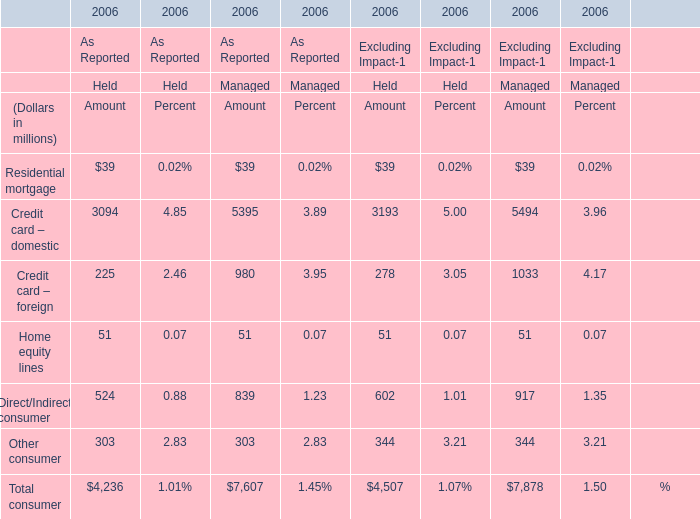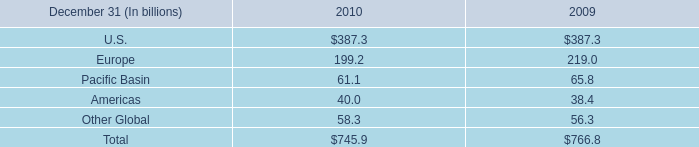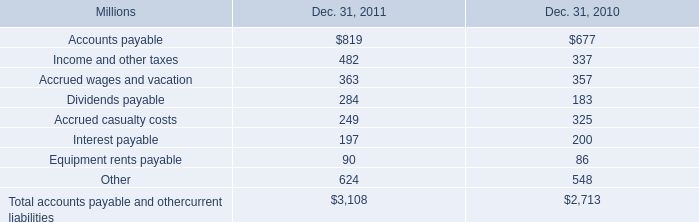In terms of one between As Reported and Excluding Impact,what is the lowest Amount of Total consumer? (in dollars in millions) 
Computations: (4236 + 7607)
Answer: 11843.0. 